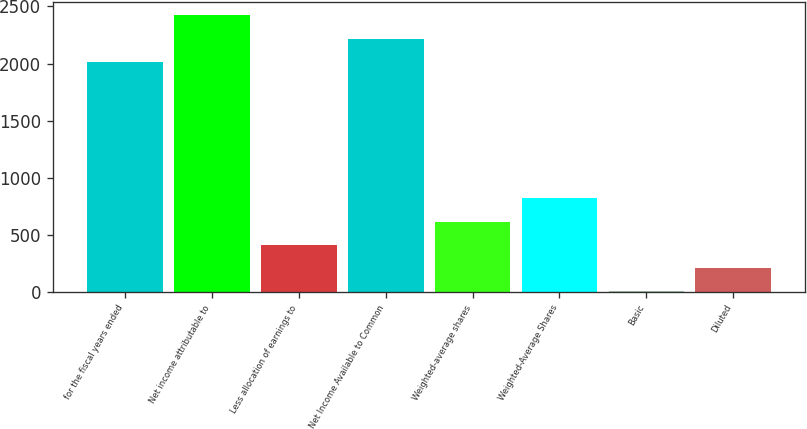<chart> <loc_0><loc_0><loc_500><loc_500><bar_chart><fcel>for the fiscal years ended<fcel>Net income attributable to<fcel>Less allocation of earnings to<fcel>Net Income Available to Common<fcel>Weighted-average shares<fcel>Weighted-Average Shares<fcel>Basic<fcel>Diluted<nl><fcel>2015<fcel>2421.4<fcel>409.69<fcel>2218.2<fcel>614.8<fcel>818<fcel>3.29<fcel>206.49<nl></chart> 